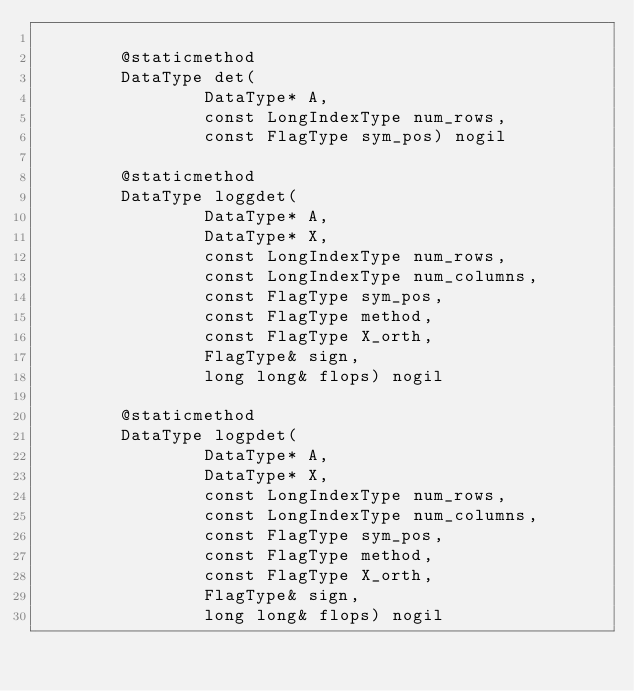Convert code to text. <code><loc_0><loc_0><loc_500><loc_500><_Cython_>
        @staticmethod
        DataType det(
                DataType* A,
                const LongIndexType num_rows,
                const FlagType sym_pos) nogil

        @staticmethod
        DataType loggdet(
                DataType* A,
                DataType* X,
                const LongIndexType num_rows,
                const LongIndexType num_columns,
                const FlagType sym_pos,
                const FlagType method,
                const FlagType X_orth,
                FlagType& sign,
                long long& flops) nogil

        @staticmethod
        DataType logpdet(
                DataType* A,
                DataType* X,
                const LongIndexType num_rows,
                const LongIndexType num_columns,
                const FlagType sym_pos,
                const FlagType method,
                const FlagType X_orth,
                FlagType& sign,
                long long& flops) nogil
</code> 